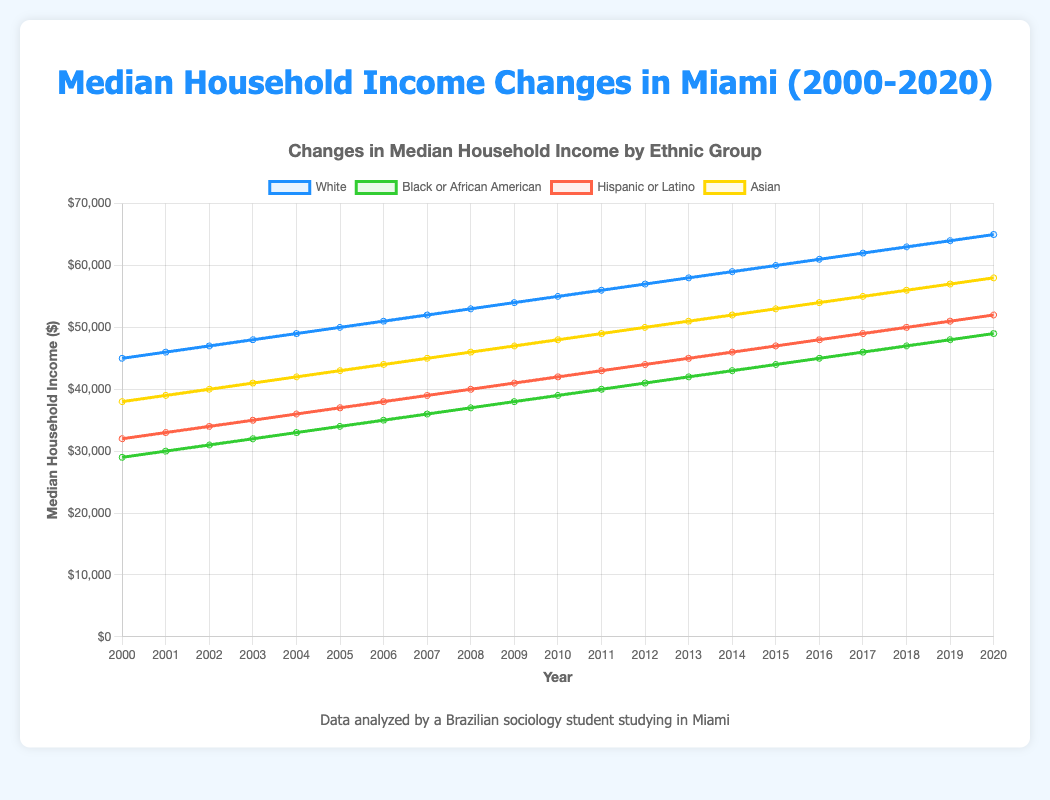Which ethnic group had the highest median household income in 2020? In the figure, identify the data points for each ethnic group in 2020. The highest value is for the Asian group at $58,000.
Answer: Asian How did the median household income for Black or African American households change from 2000 to 2020? In the figure, observe the data points for Black or African American households in 2000 and 2020. The income increased from $29,000 to $49,000.
Answer: Increased by $20,000 Which ethnic group experienced the smallest overall increase in median household income from 2000 to 2020? Calculate the difference between the 2020 and 2000 values for each group and compare. Black or African American households increased from $29,000 to $49,000 (an increase of $20,000), which is the smallest among all groups.
Answer: Black or African American By how much did the median household income for Hispanic or Latino households grow from 2005 to 2010? Subtract the 2005 income ($37,000) from the 2010 income ($42,000). The increase is $42,000 - $37,000 = $5,000.
Answer: $5,000 In what year did Asian households surpass a median income of $50,000? Locate the data points for Asian households and check the year when the income first exceeded $50,000. This occurs in 2012.
Answer: 2012 Which ethnic group had the steepest increase in median household income from 2000 to 2020? Calculate the absolute change for each group: White ($65,000 - $45,000 = $20,000), Black or African American ($49,000 - $29,000 = $20,000), Hispanic or Latino ($52,000 - $32,000 = $20,000), Asian ($58,000 - $38,000 = $20,000). Each group had the same increase.
Answer: All groups equally Did the median household income for any group decline between any two consecutive years? Examine the data points for each group over the years. No group’s income declined between any two consecutive years.
Answer: No Which ethnic group had the second highest median household income in 2010? Check the data points for each group in 2010 and rank them. The second highest is the Asian group at $48,000.
Answer: Asian Find the average median household income for Hispanic or Latino households from 2000 to 2020. Sum all yearly values from 2000 to 2020 and divide by the number of years: (32,000 + 33,000 + 34,000 + 35,000 + 36,000 + 37,000 + 38,000 + 39,000 + 40,000 + 41,000 + 42,000 + 43,000 + 44,000 + 45,000 + 46,000 + 47,000 + 48,000 + 49,000 + 50,000 + 51,000 + 52,000) / 21 = $41,000.
Answer: $41,000 Who had the largest median income gap, White or Asian households, between 2005 and 2015? Calculate the difference between 2015 and 2005 for White ($60,000 - $50,000 = $10,000) and Asian ($53,000 - $43,000 = $10,000). Both groups had an equal gap.
Answer: Both equally 